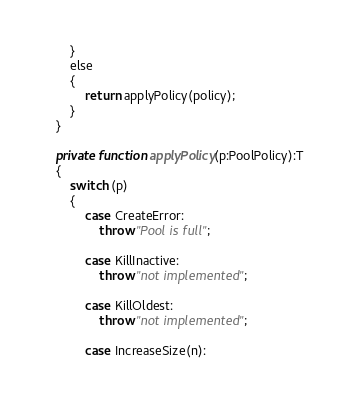Convert code to text. <code><loc_0><loc_0><loc_500><loc_500><_Haxe_>        }
        else
        {
            return applyPolicy(policy);
        }
    }
    
    private function applyPolicy(p:PoolPolicy):T
    {
        switch (p)
        {
            case CreateError:
                throw "Pool is full";
                
            case KillInactive:
                throw "not implemented";
                
            case KillOldest:
                throw "not implemented";
                
            case IncreaseSize(n):</code> 